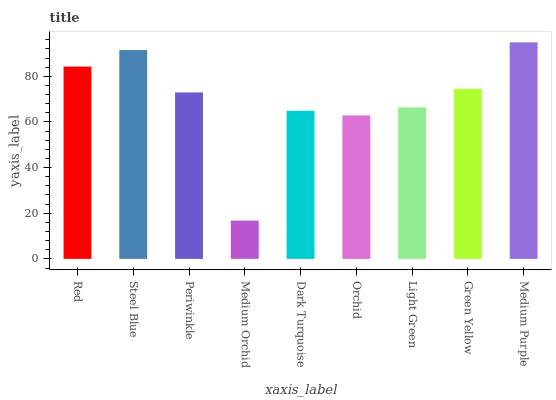Is Steel Blue the minimum?
Answer yes or no. No. Is Steel Blue the maximum?
Answer yes or no. No. Is Steel Blue greater than Red?
Answer yes or no. Yes. Is Red less than Steel Blue?
Answer yes or no. Yes. Is Red greater than Steel Blue?
Answer yes or no. No. Is Steel Blue less than Red?
Answer yes or no. No. Is Periwinkle the high median?
Answer yes or no. Yes. Is Periwinkle the low median?
Answer yes or no. Yes. Is Medium Purple the high median?
Answer yes or no. No. Is Dark Turquoise the low median?
Answer yes or no. No. 